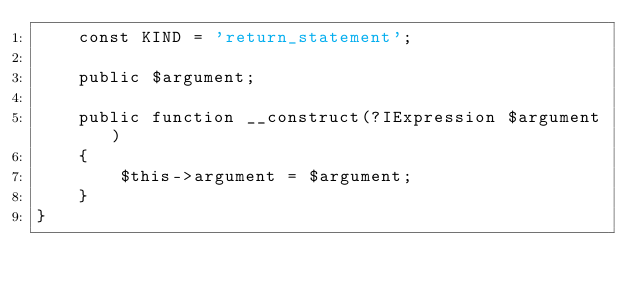<code> <loc_0><loc_0><loc_500><loc_500><_PHP_>	const KIND = 'return_statement';

	public $argument;

	public function __construct(?IExpression $argument)
	{
		$this->argument = $argument;
	}
}
</code> 